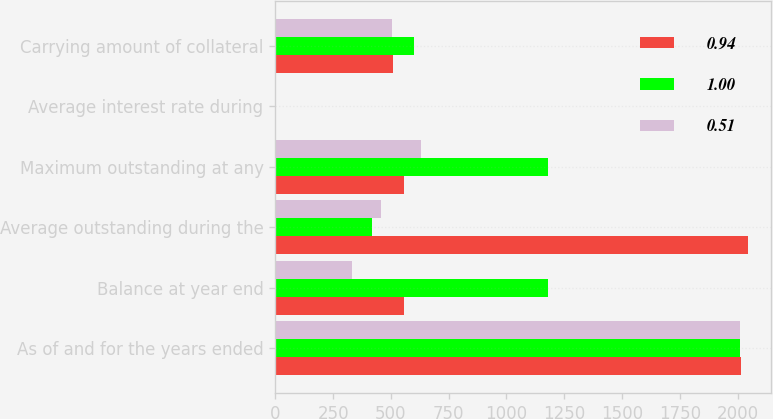<chart> <loc_0><loc_0><loc_500><loc_500><stacked_bar_chart><ecel><fcel>As of and for the years ended<fcel>Balance at year end<fcel>Average outstanding during the<fcel>Maximum outstanding at any<fcel>Average interest rate during<fcel>Carrying amount of collateral<nl><fcel>0.94<fcel>2013<fcel>555.55<fcel>2043.9<fcel>555.55<fcel>0.4<fcel>511.2<nl><fcel>1<fcel>2012<fcel>1178.3<fcel>419.5<fcel>1178.3<fcel>1.23<fcel>599.9<nl><fcel>0.51<fcel>2011<fcel>332.4<fcel>456.1<fcel>631.9<fcel>1.48<fcel>505.7<nl></chart> 